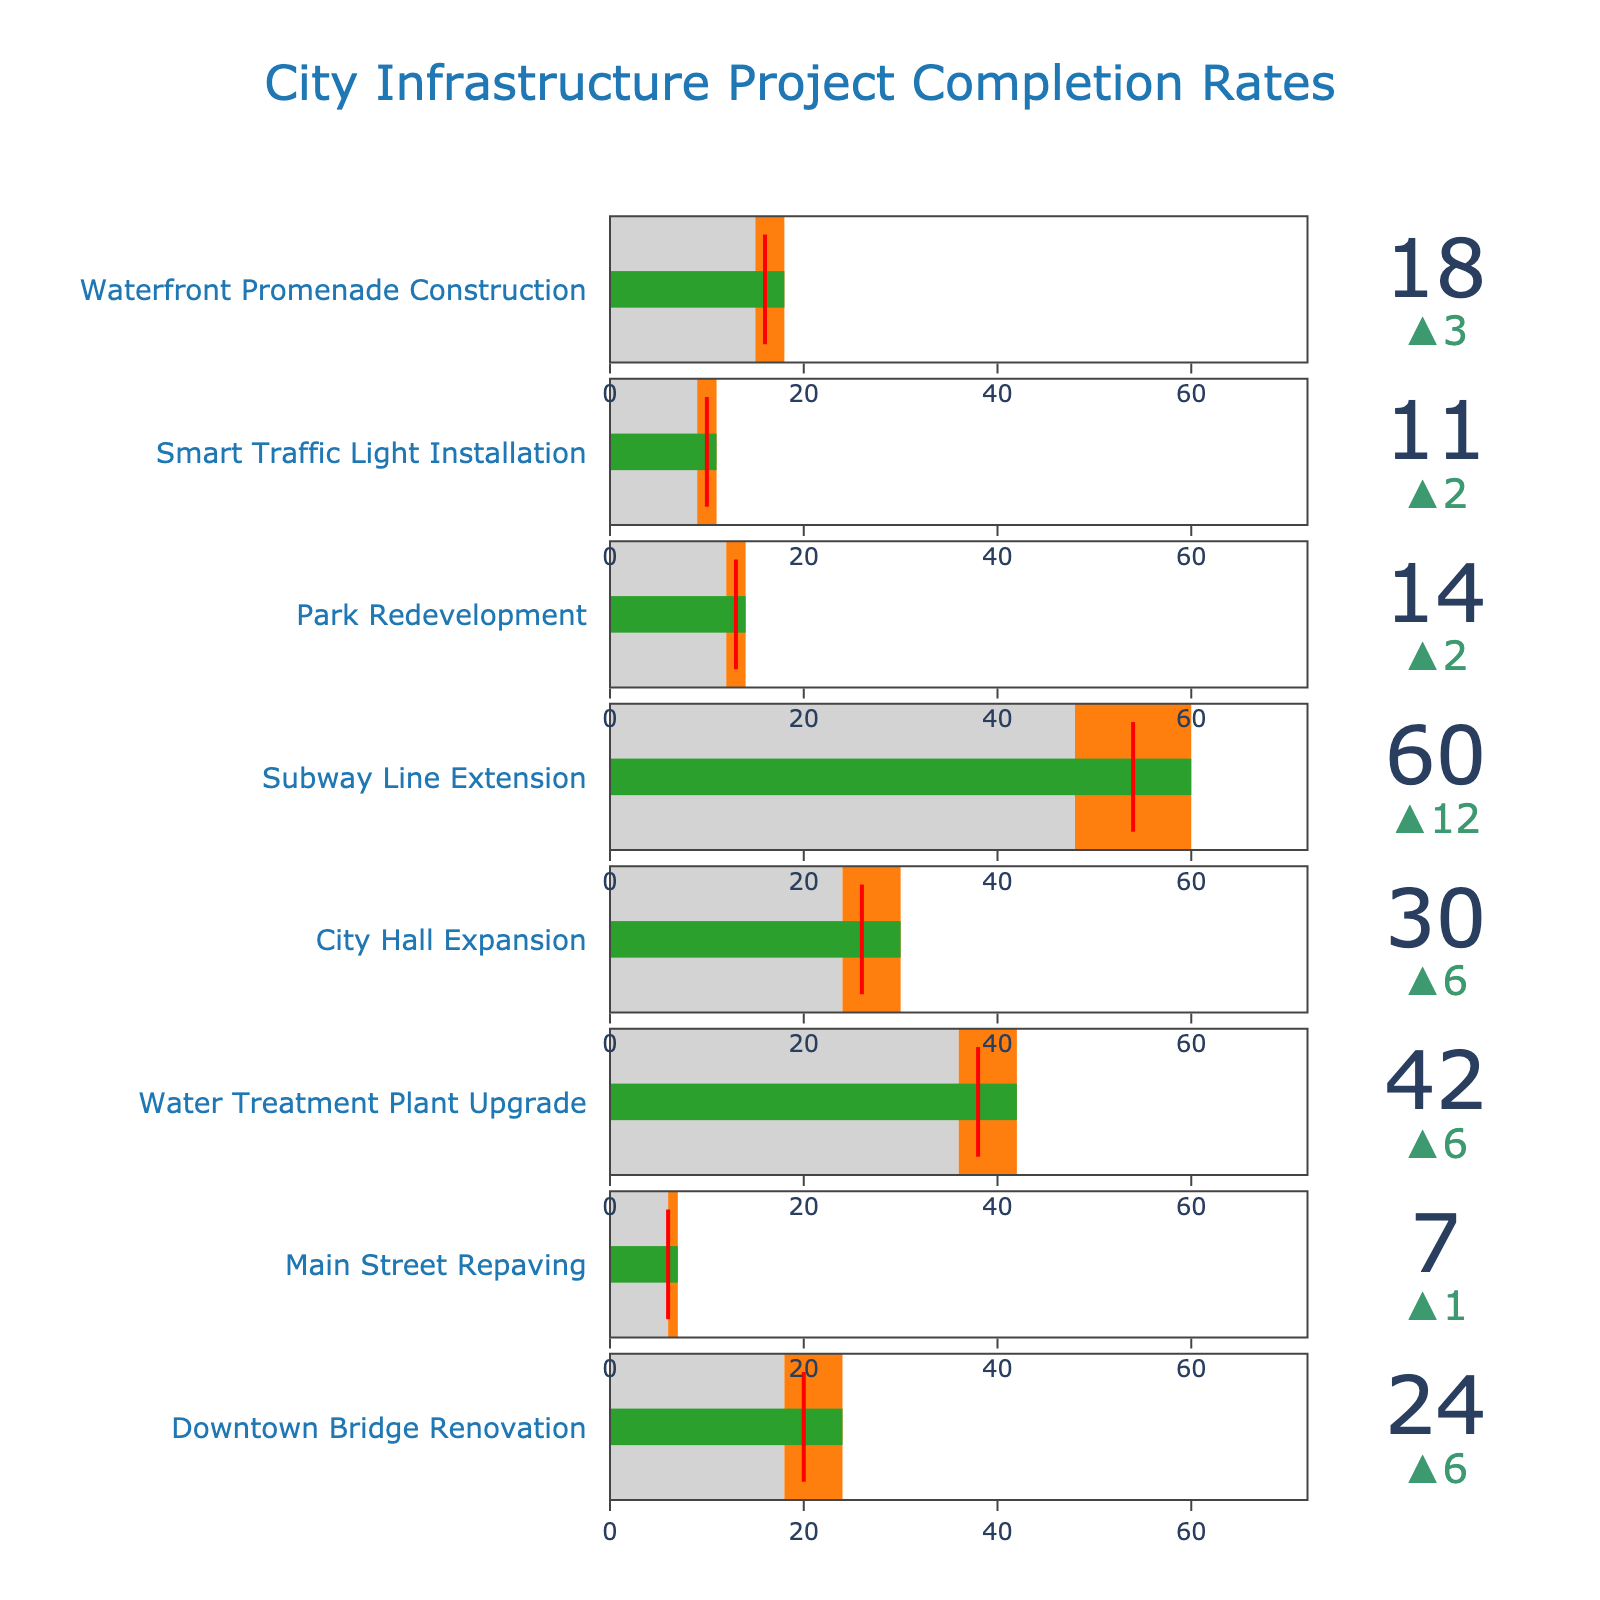What's the title of the chart? The title is located at the top center of the chart and reads "City Infrastructure Project Completion Rates."
Answer: City Infrastructure Project Completion Rates How many projects are displayed in the chart? Each row in the chart represents a project, and counting the rows shows there are 8 projects displayed.
Answer: 8 What is the planned completion time for the Subway Line Extension project? Locate the row titled "Subway Line Extension" and find the planned completion time, which is 48 months.
Answer: 48 months Which project had the longest actual completion time? Compare the "Actual Completion (months)" values for all projects, and the "Subway Line Extension" has the highest value at 60 months.
Answer: Subway Line Extension By how many months did the Water Treatment Plant Upgrade project exceed its planned completion time? Subtract the planned completion time (36 months) from the actual completion time (42 months) for the Water Treatment Plant Upgrade project (42 - 36 = 6 months).
Answer: 6 months Which project had the smallest delay compared to its planned timeline? Identify the project with the minimal difference between actual and planned completion times, which is "Main Street Repaving" (planned: 6 months, actual: 7 months, difference: 1 month).
Answer: Main Street Repaving What is the average planned completion time across all projects? Sum the planned completion times of all projects (18 + 6 + 36 + 24 + 48 + 12 + 9 + 15 = 168 months) and divide by the number of projects (168 / 8 = 21 months).
Answer: 21 months How does the actual completion time of the Park Redevelopment compare to the city average? Check the actual completion time (14 months) and the city average (13 months) for the "Park Redevelopment" project. The actual completion time is 1 month more than the city average.
Answer: 1 month more Which project has the closest actual completion time to its city average? Compare the actual completion times and the city averages for all projects. The "Main Street Repaving" project matches its city average exactly (7 months).
Answer: Main Street Repaving What is the color used to represent the steps between planned and actual completion times in the bullet gauge? The color used for the steps between planned and actual completion times is orange.
Answer: orange 